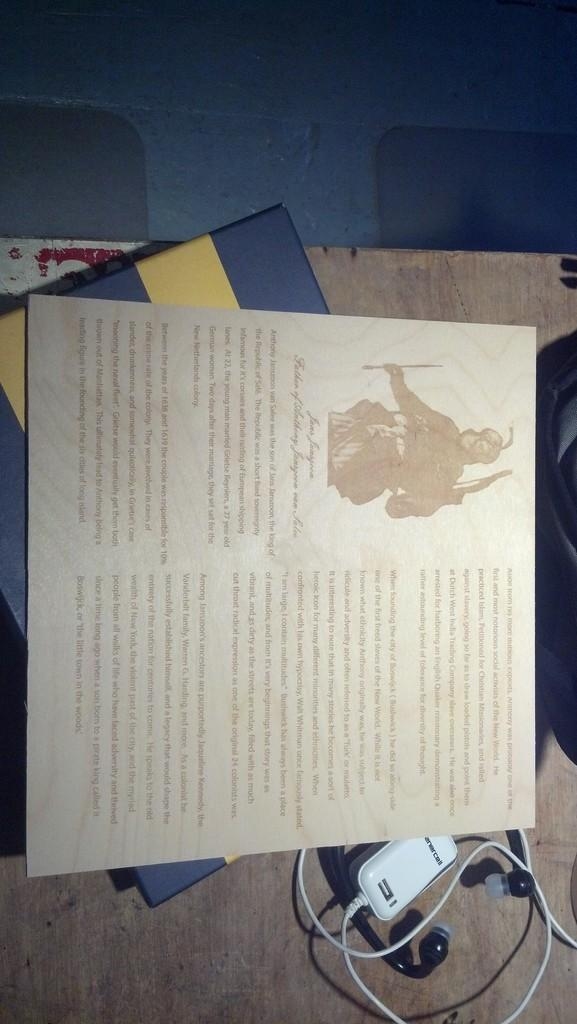What objects are on the wooden table in the image? There are books on the wooden table in the image. What type of surface is visible beneath the table? There is a floor visible in the image. What electronic device and its accessory can be seen at the bottom right of the image? There are earphones along with a charger at the bottom right of the image. How far away is the baby from the goose in the image? There is no baby or goose present in the image. 